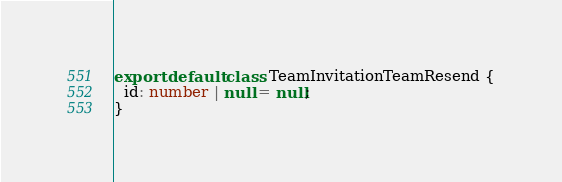Convert code to text. <code><loc_0><loc_0><loc_500><loc_500><_TypeScript_>export default class TeamInvitationTeamResend {
  id: number | null = null;
}</code> 